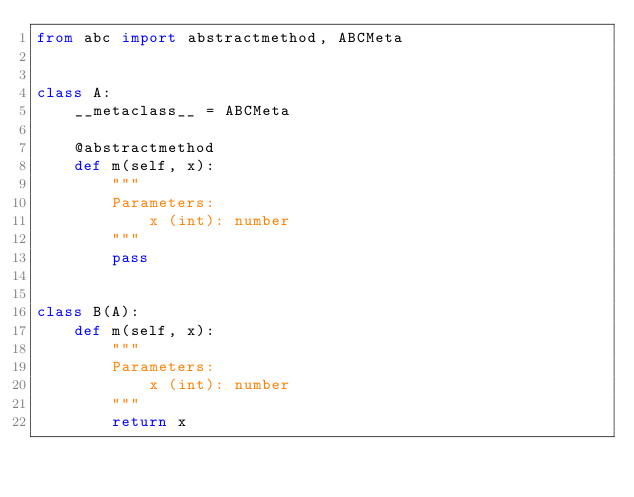Convert code to text. <code><loc_0><loc_0><loc_500><loc_500><_Python_>from abc import abstractmethod, ABCMeta


class A:
    __metaclass__ = ABCMeta

    @abstractmethod
    def m(self, x):
        """
        Parameters:
            x (int): number
        """
        pass


class B(A):
    def m(self, x):
        """
        Parameters:
            x (int): number
        """
        return x
</code> 